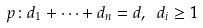<formula> <loc_0><loc_0><loc_500><loc_500>p \colon d _ { 1 } + \dots + d _ { n } = d , \ d _ { i } \geq 1</formula> 